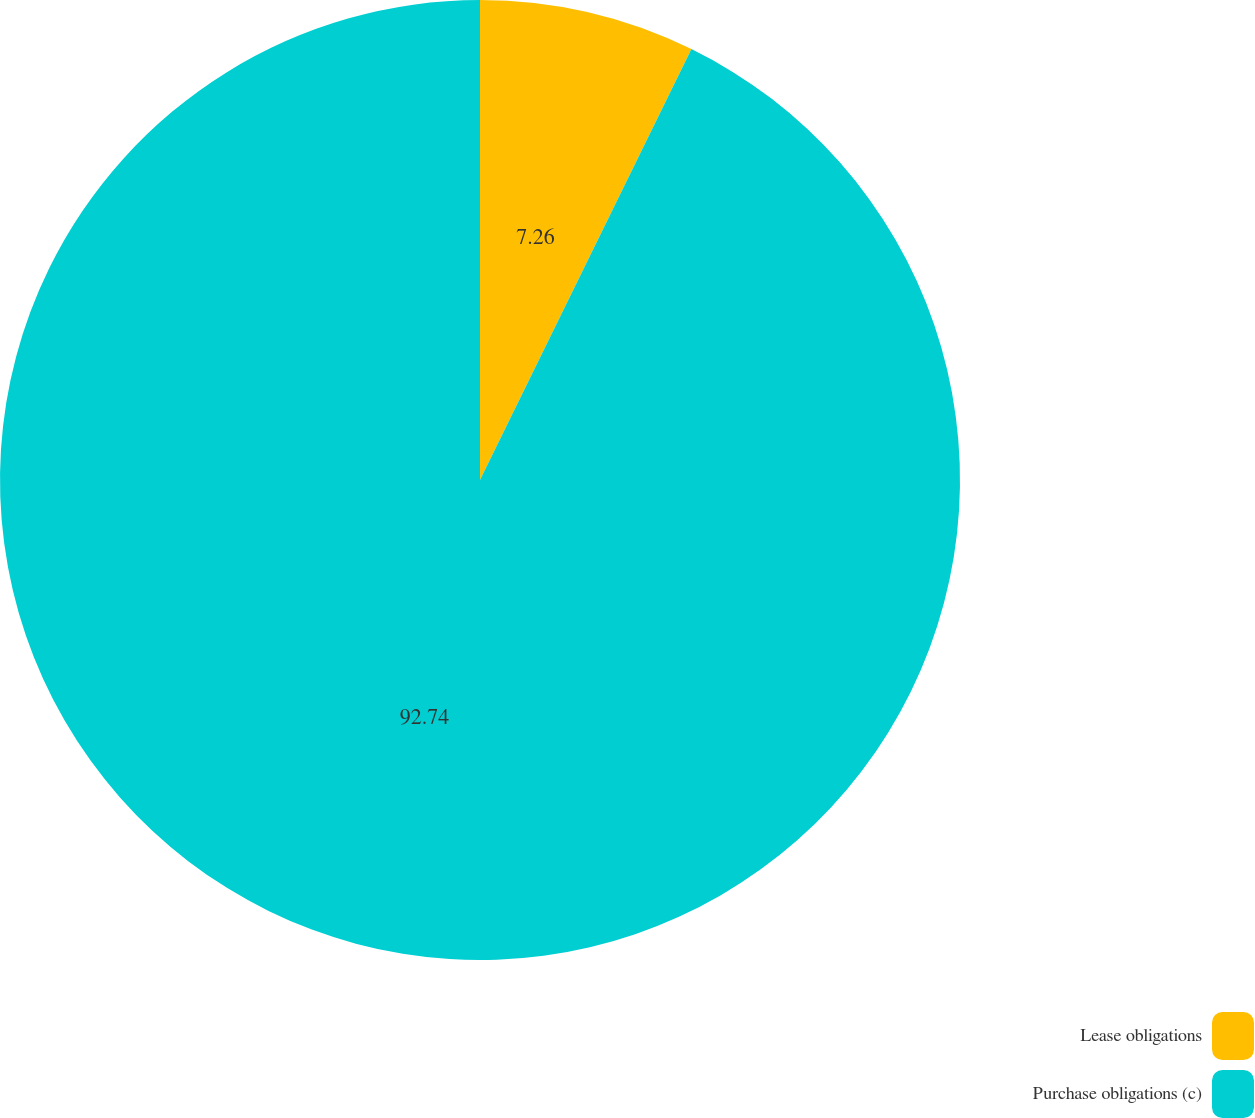<chart> <loc_0><loc_0><loc_500><loc_500><pie_chart><fcel>Lease obligations<fcel>Purchase obligations (c)<nl><fcel>7.26%<fcel>92.74%<nl></chart> 